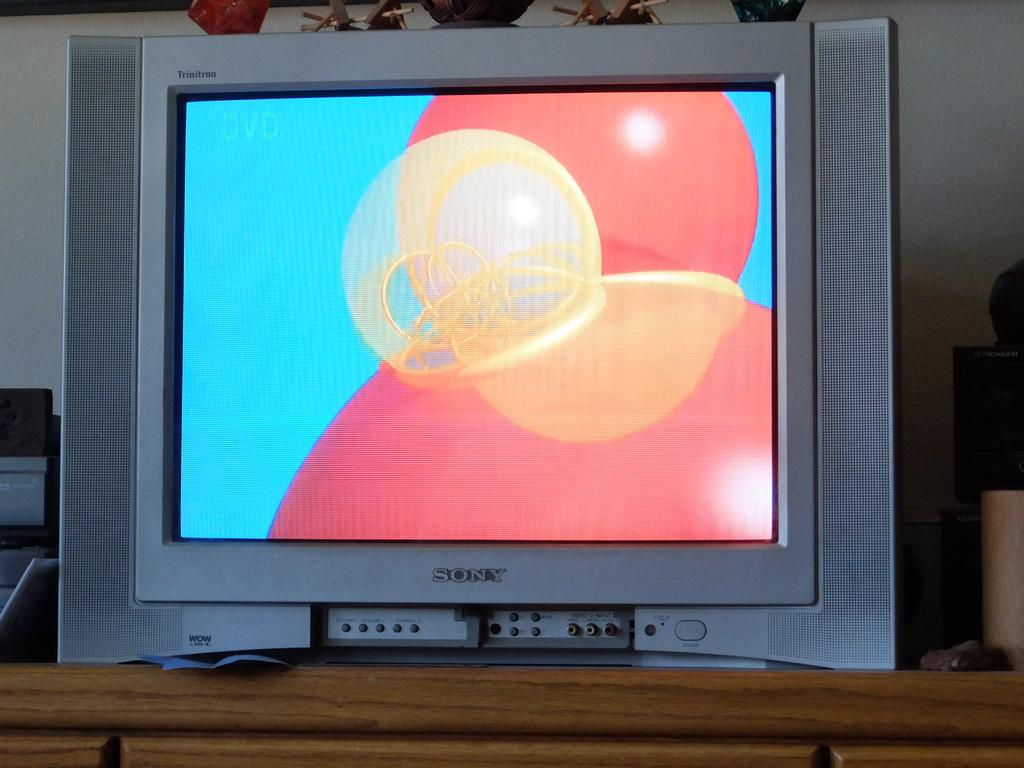<image>
Present a compact description of the photo's key features. A Sony Trinitron TV is sitting on a shelf. 